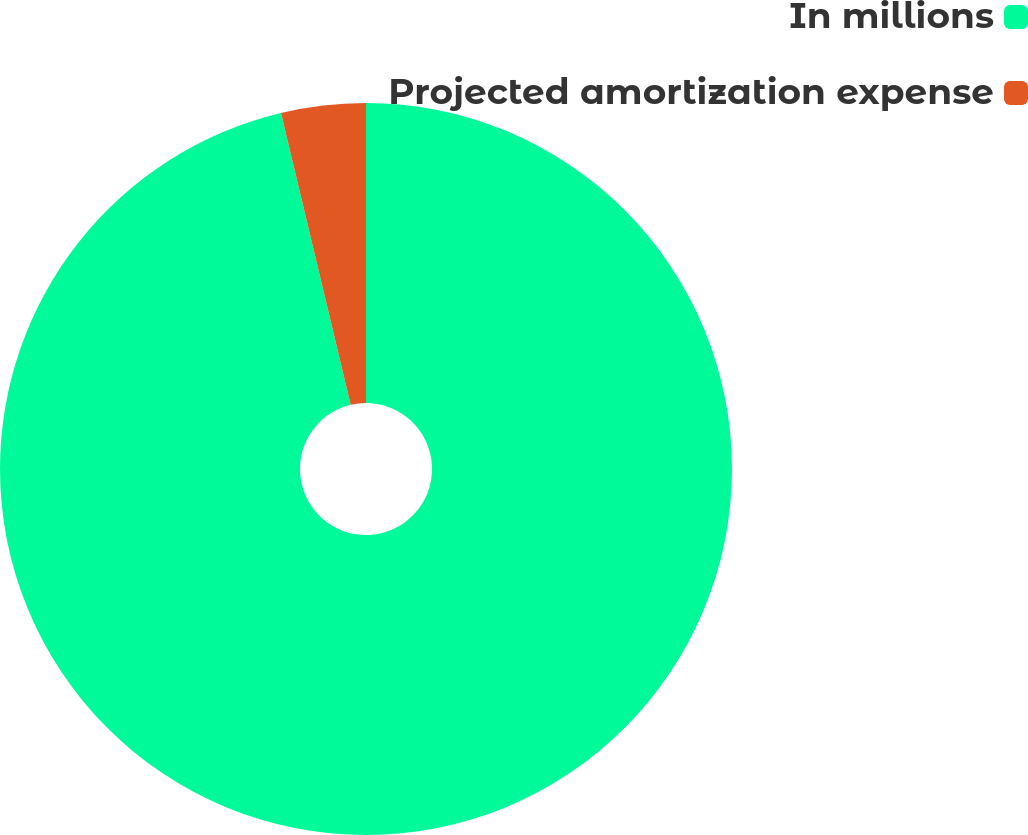Convert chart to OTSL. <chart><loc_0><loc_0><loc_500><loc_500><pie_chart><fcel>In millions<fcel>Projected amortization expense<nl><fcel>96.27%<fcel>3.73%<nl></chart> 